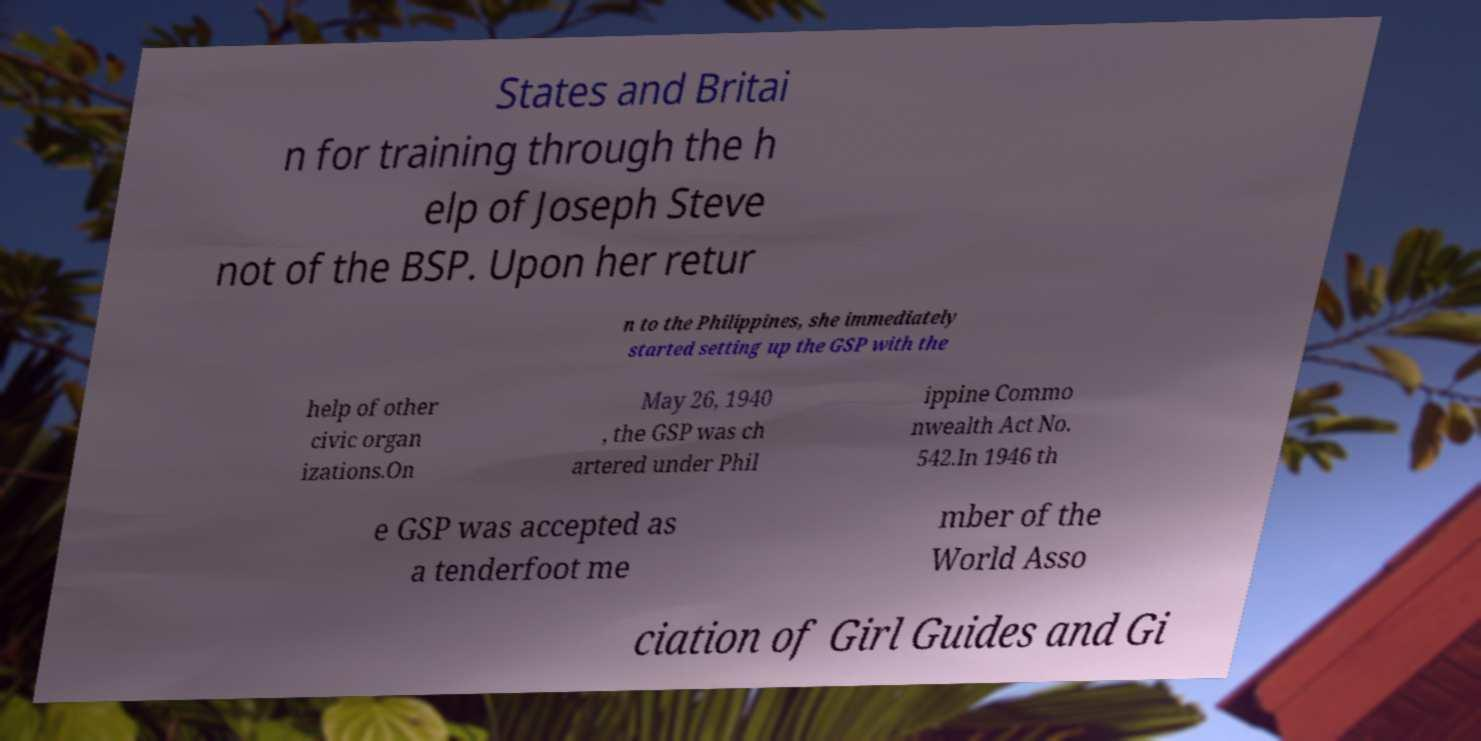Could you extract and type out the text from this image? States and Britai n for training through the h elp of Joseph Steve not of the BSP. Upon her retur n to the Philippines, she immediately started setting up the GSP with the help of other civic organ izations.On May 26, 1940 , the GSP was ch artered under Phil ippine Commo nwealth Act No. 542.In 1946 th e GSP was accepted as a tenderfoot me mber of the World Asso ciation of Girl Guides and Gi 